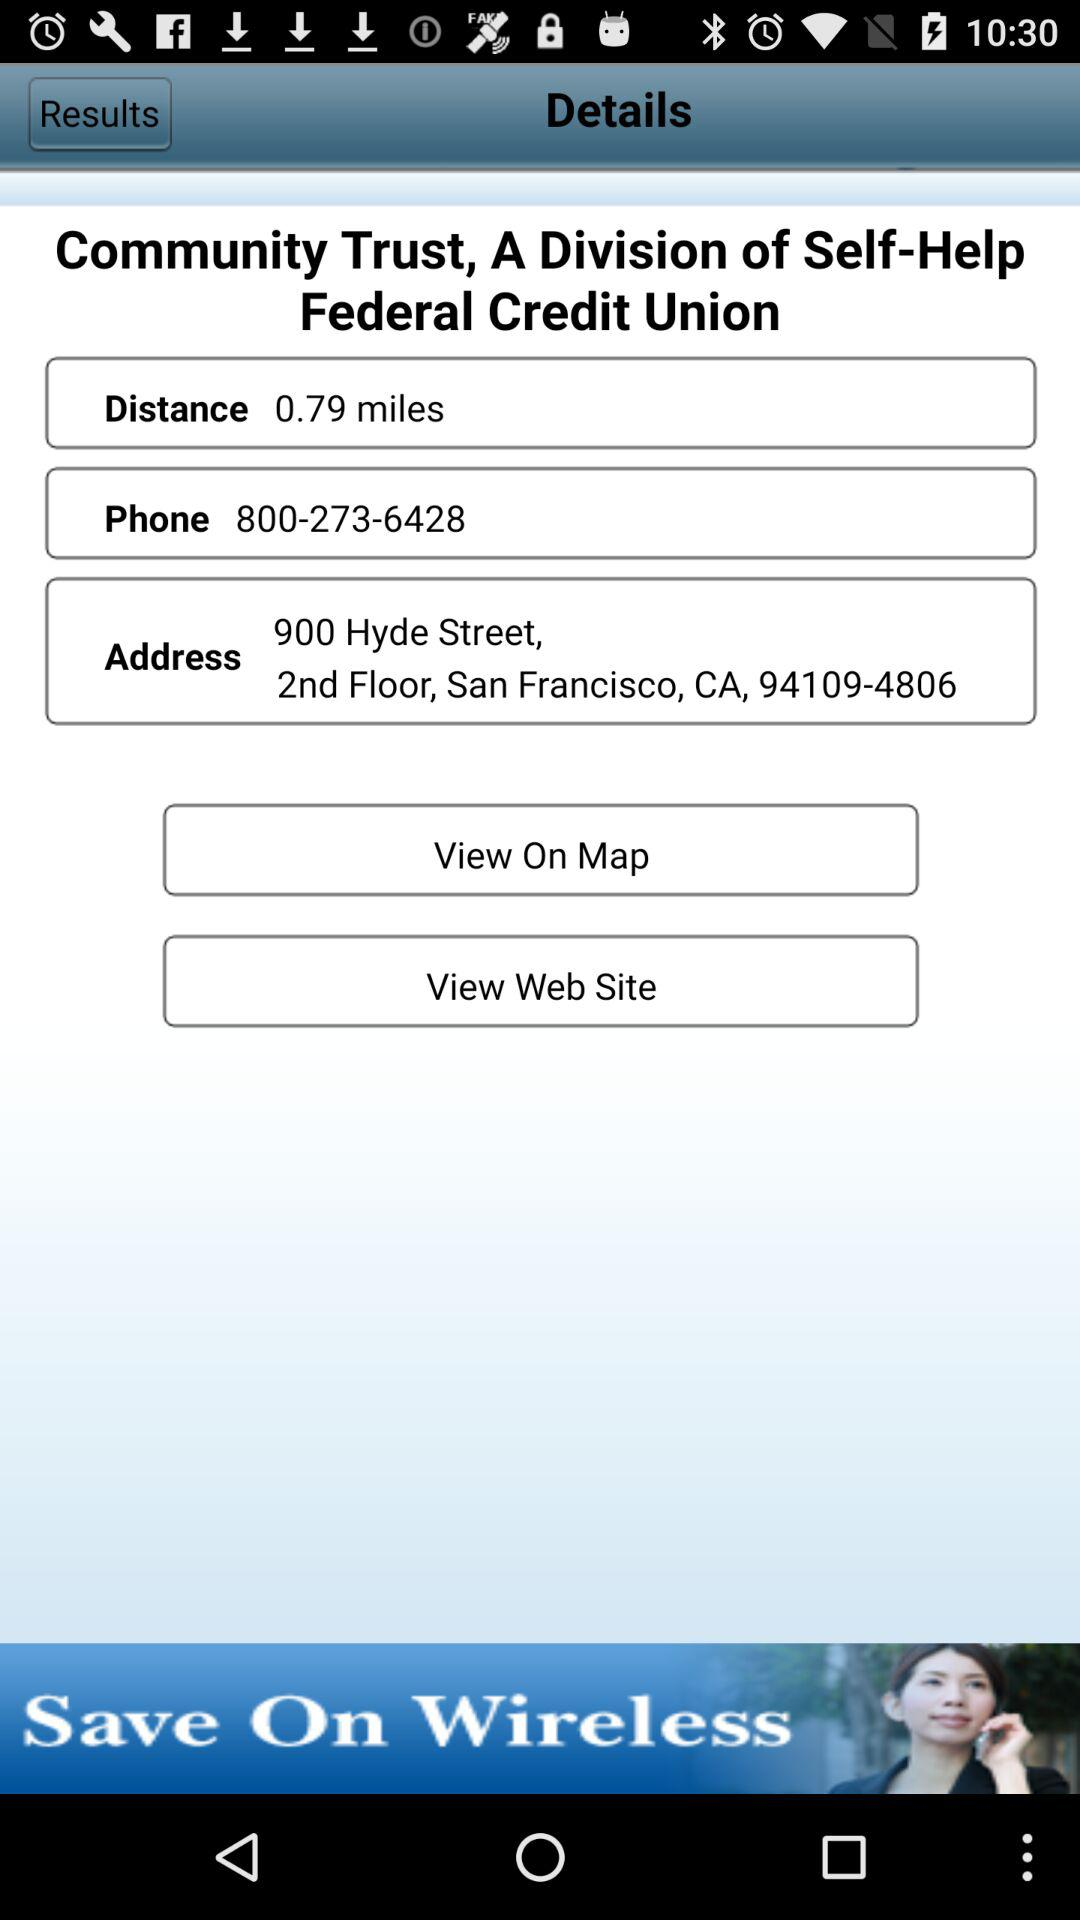What is the address? The address is 900 Hyde Street, 2nd Floor, San Francisco, CA, 94109-4806. 